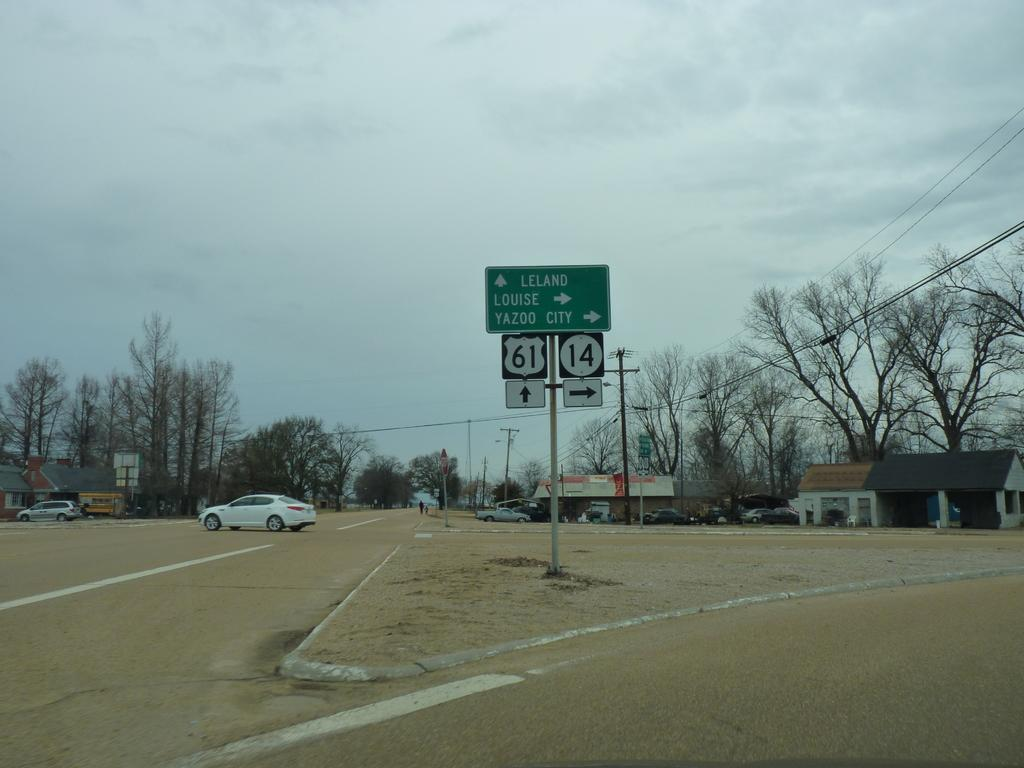<image>
Write a terse but informative summary of the picture. A street with a navigation sign of Leland going forward, and Louise and Yazoo City to the right. 